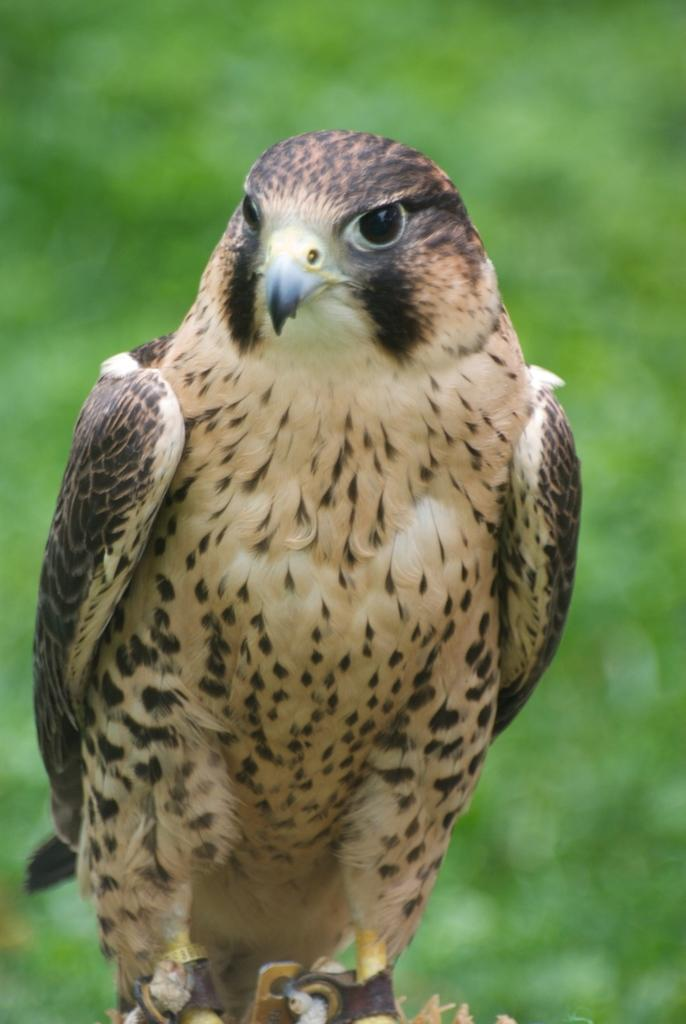What type of bird is in the image? There is a red-tailed hawk in the image. How are the hawk's legs secured in the image? The hawk's legs are tied with a belt. Can you describe the background of the image? The background of the image is blurry. What organization is responsible for the duck in the image? There is no duck present in the image, so it is not possible to determine which organization might be responsible for it. 